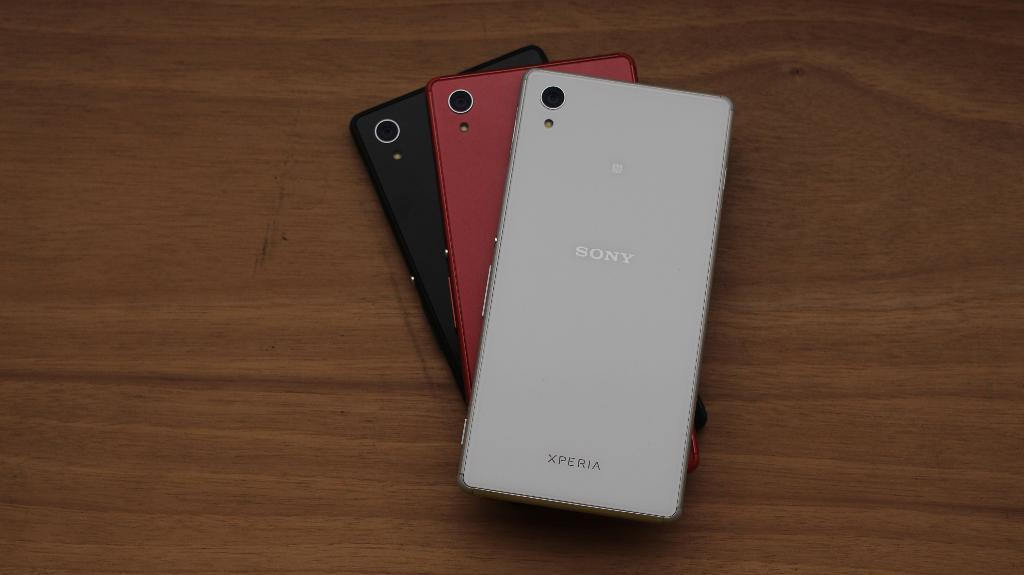Provide a one-sentence caption for the provided image. Three Sony mobile phones, one red one black one white,  sit one on top the other but fanned out so the reverse of all three is visible. 